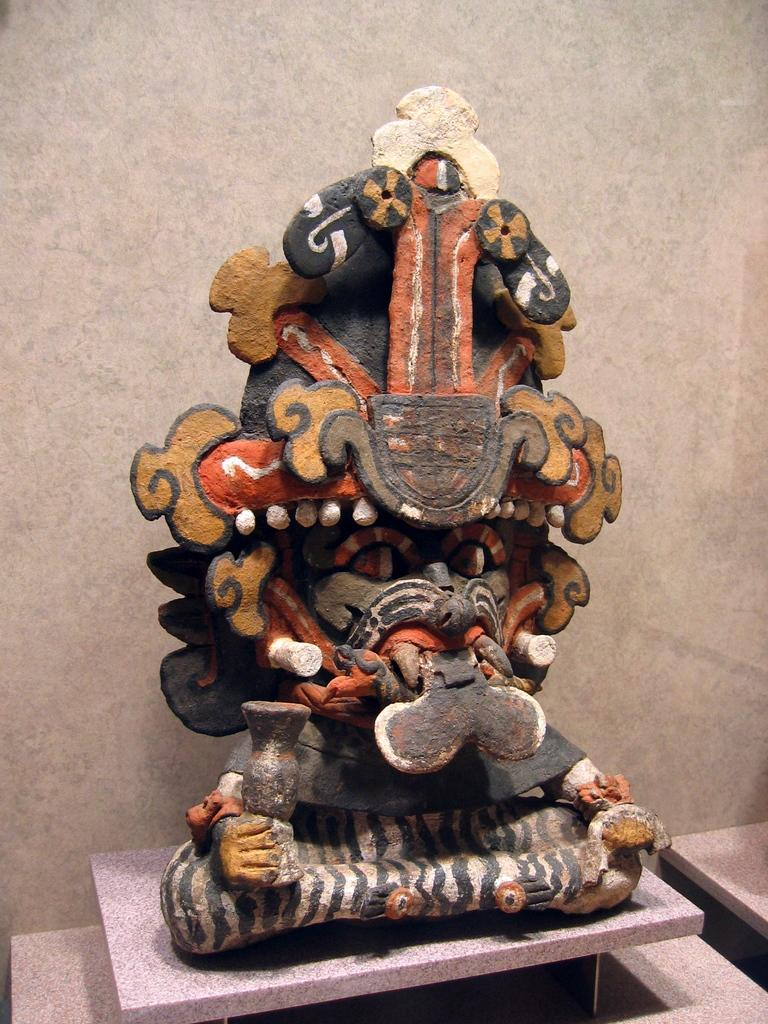What is the main subject of the image? There is a statue in the image. Where is the statue located? The statue is on a platform. What can be seen in the background of the image? There is a wall in the background of the image. How many sisters are depicted in the image? There are no sisters depicted in the image; it features a statue on a platform with a wall in the background. What type of car can be seen driving past the statue in the image? There is no car present in the image; it only features a statue on a platform and a wall in the background. 